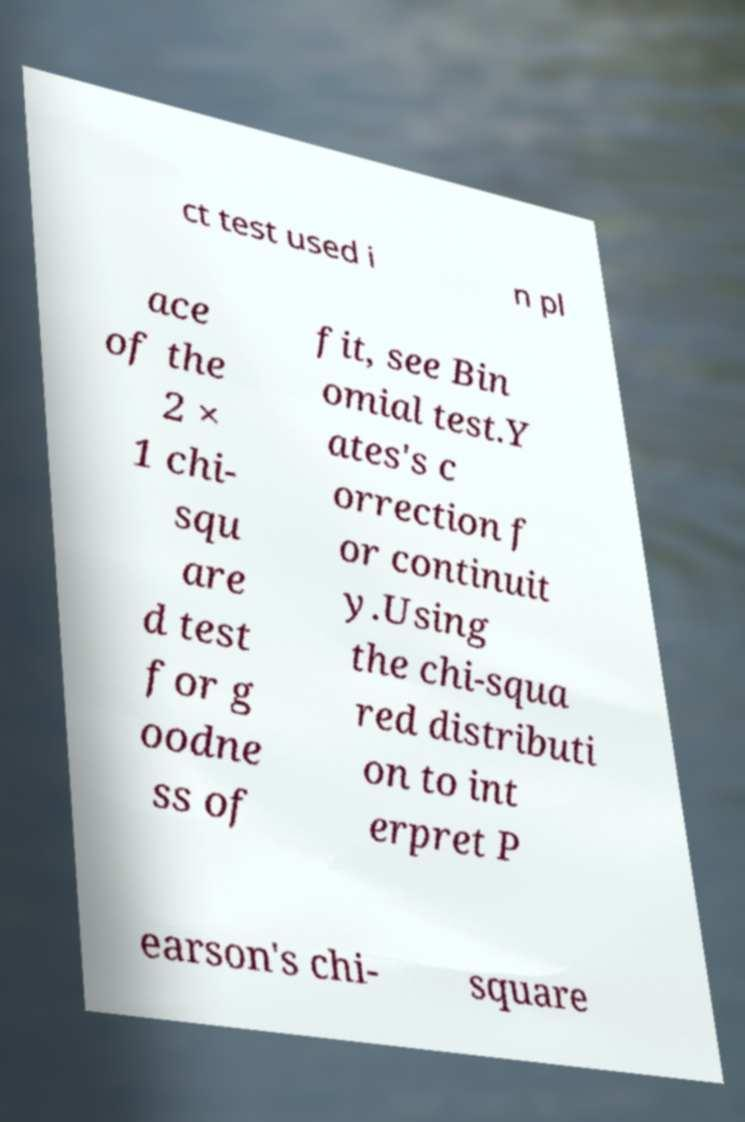Could you assist in decoding the text presented in this image and type it out clearly? ct test used i n pl ace of the 2 × 1 chi- squ are d test for g oodne ss of fit, see Bin omial test.Y ates's c orrection f or continuit y.Using the chi-squa red distributi on to int erpret P earson's chi- square 